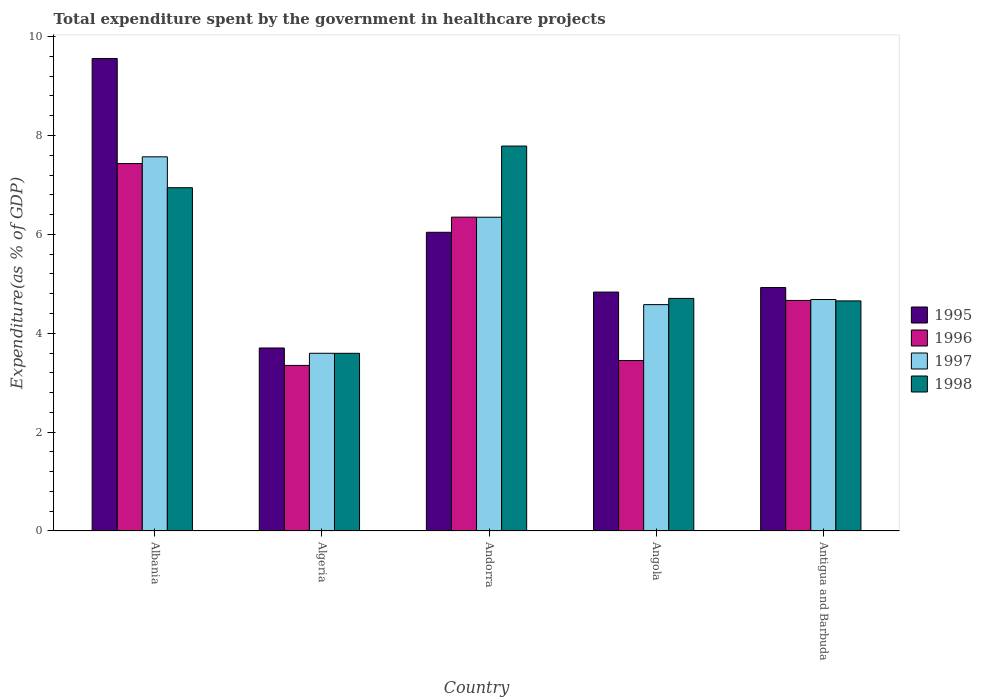How many different coloured bars are there?
Give a very brief answer. 4. How many groups of bars are there?
Keep it short and to the point. 5. Are the number of bars on each tick of the X-axis equal?
Offer a terse response. Yes. How many bars are there on the 3rd tick from the right?
Your answer should be compact. 4. What is the label of the 2nd group of bars from the left?
Provide a short and direct response. Algeria. In how many cases, is the number of bars for a given country not equal to the number of legend labels?
Your answer should be compact. 0. What is the total expenditure spent by the government in healthcare projects in 1998 in Andorra?
Ensure brevity in your answer.  7.79. Across all countries, what is the maximum total expenditure spent by the government in healthcare projects in 1998?
Provide a succinct answer. 7.79. Across all countries, what is the minimum total expenditure spent by the government in healthcare projects in 1995?
Provide a short and direct response. 3.7. In which country was the total expenditure spent by the government in healthcare projects in 1996 maximum?
Make the answer very short. Albania. In which country was the total expenditure spent by the government in healthcare projects in 1997 minimum?
Ensure brevity in your answer.  Algeria. What is the total total expenditure spent by the government in healthcare projects in 1998 in the graph?
Your answer should be very brief. 27.68. What is the difference between the total expenditure spent by the government in healthcare projects in 1998 in Albania and that in Algeria?
Provide a succinct answer. 3.35. What is the difference between the total expenditure spent by the government in healthcare projects in 1995 in Algeria and the total expenditure spent by the government in healthcare projects in 1998 in Albania?
Provide a succinct answer. -3.24. What is the average total expenditure spent by the government in healthcare projects in 1995 per country?
Your response must be concise. 5.81. What is the difference between the total expenditure spent by the government in healthcare projects of/in 1998 and total expenditure spent by the government in healthcare projects of/in 1997 in Algeria?
Give a very brief answer. -0. What is the ratio of the total expenditure spent by the government in healthcare projects in 1998 in Andorra to that in Antigua and Barbuda?
Offer a very short reply. 1.67. Is the total expenditure spent by the government in healthcare projects in 1996 in Albania less than that in Andorra?
Ensure brevity in your answer.  No. What is the difference between the highest and the second highest total expenditure spent by the government in healthcare projects in 1995?
Offer a terse response. 4.63. What is the difference between the highest and the lowest total expenditure spent by the government in healthcare projects in 1997?
Your answer should be very brief. 3.97. In how many countries, is the total expenditure spent by the government in healthcare projects in 1995 greater than the average total expenditure spent by the government in healthcare projects in 1995 taken over all countries?
Your response must be concise. 2. What does the 4th bar from the left in Angola represents?
Ensure brevity in your answer.  1998. Is it the case that in every country, the sum of the total expenditure spent by the government in healthcare projects in 1995 and total expenditure spent by the government in healthcare projects in 1996 is greater than the total expenditure spent by the government in healthcare projects in 1997?
Give a very brief answer. Yes. Are all the bars in the graph horizontal?
Your response must be concise. No. What is the difference between two consecutive major ticks on the Y-axis?
Your response must be concise. 2. Are the values on the major ticks of Y-axis written in scientific E-notation?
Provide a succinct answer. No. Does the graph contain grids?
Provide a short and direct response. No. What is the title of the graph?
Provide a short and direct response. Total expenditure spent by the government in healthcare projects. What is the label or title of the X-axis?
Your response must be concise. Country. What is the label or title of the Y-axis?
Give a very brief answer. Expenditure(as % of GDP). What is the Expenditure(as % of GDP) in 1995 in Albania?
Your answer should be compact. 9.56. What is the Expenditure(as % of GDP) in 1996 in Albania?
Provide a short and direct response. 7.43. What is the Expenditure(as % of GDP) of 1997 in Albania?
Ensure brevity in your answer.  7.57. What is the Expenditure(as % of GDP) in 1998 in Albania?
Your response must be concise. 6.94. What is the Expenditure(as % of GDP) of 1995 in Algeria?
Your response must be concise. 3.7. What is the Expenditure(as % of GDP) in 1996 in Algeria?
Make the answer very short. 3.35. What is the Expenditure(as % of GDP) in 1997 in Algeria?
Your response must be concise. 3.59. What is the Expenditure(as % of GDP) of 1998 in Algeria?
Keep it short and to the point. 3.59. What is the Expenditure(as % of GDP) in 1995 in Andorra?
Your answer should be very brief. 6.04. What is the Expenditure(as % of GDP) of 1996 in Andorra?
Keep it short and to the point. 6.35. What is the Expenditure(as % of GDP) of 1997 in Andorra?
Your answer should be very brief. 6.35. What is the Expenditure(as % of GDP) of 1998 in Andorra?
Offer a very short reply. 7.79. What is the Expenditure(as % of GDP) of 1995 in Angola?
Your answer should be very brief. 4.83. What is the Expenditure(as % of GDP) in 1996 in Angola?
Your answer should be very brief. 3.45. What is the Expenditure(as % of GDP) in 1997 in Angola?
Your response must be concise. 4.58. What is the Expenditure(as % of GDP) of 1998 in Angola?
Ensure brevity in your answer.  4.7. What is the Expenditure(as % of GDP) of 1995 in Antigua and Barbuda?
Your answer should be very brief. 4.92. What is the Expenditure(as % of GDP) of 1996 in Antigua and Barbuda?
Offer a very short reply. 4.66. What is the Expenditure(as % of GDP) in 1997 in Antigua and Barbuda?
Your response must be concise. 4.68. What is the Expenditure(as % of GDP) in 1998 in Antigua and Barbuda?
Offer a very short reply. 4.65. Across all countries, what is the maximum Expenditure(as % of GDP) of 1995?
Your response must be concise. 9.56. Across all countries, what is the maximum Expenditure(as % of GDP) in 1996?
Your answer should be very brief. 7.43. Across all countries, what is the maximum Expenditure(as % of GDP) in 1997?
Provide a short and direct response. 7.57. Across all countries, what is the maximum Expenditure(as % of GDP) of 1998?
Your answer should be very brief. 7.79. Across all countries, what is the minimum Expenditure(as % of GDP) in 1995?
Your answer should be compact. 3.7. Across all countries, what is the minimum Expenditure(as % of GDP) in 1996?
Your response must be concise. 3.35. Across all countries, what is the minimum Expenditure(as % of GDP) in 1997?
Your answer should be compact. 3.59. Across all countries, what is the minimum Expenditure(as % of GDP) in 1998?
Ensure brevity in your answer.  3.59. What is the total Expenditure(as % of GDP) in 1995 in the graph?
Keep it short and to the point. 29.06. What is the total Expenditure(as % of GDP) of 1996 in the graph?
Your answer should be very brief. 25.24. What is the total Expenditure(as % of GDP) in 1997 in the graph?
Ensure brevity in your answer.  26.77. What is the total Expenditure(as % of GDP) in 1998 in the graph?
Provide a short and direct response. 27.68. What is the difference between the Expenditure(as % of GDP) in 1995 in Albania and that in Algeria?
Your response must be concise. 5.86. What is the difference between the Expenditure(as % of GDP) of 1996 in Albania and that in Algeria?
Keep it short and to the point. 4.08. What is the difference between the Expenditure(as % of GDP) in 1997 in Albania and that in Algeria?
Your response must be concise. 3.97. What is the difference between the Expenditure(as % of GDP) in 1998 in Albania and that in Algeria?
Provide a short and direct response. 3.35. What is the difference between the Expenditure(as % of GDP) in 1995 in Albania and that in Andorra?
Provide a short and direct response. 3.52. What is the difference between the Expenditure(as % of GDP) in 1996 in Albania and that in Andorra?
Offer a terse response. 1.08. What is the difference between the Expenditure(as % of GDP) in 1997 in Albania and that in Andorra?
Your answer should be very brief. 1.22. What is the difference between the Expenditure(as % of GDP) in 1998 in Albania and that in Andorra?
Offer a terse response. -0.84. What is the difference between the Expenditure(as % of GDP) of 1995 in Albania and that in Angola?
Offer a very short reply. 4.72. What is the difference between the Expenditure(as % of GDP) in 1996 in Albania and that in Angola?
Make the answer very short. 3.98. What is the difference between the Expenditure(as % of GDP) of 1997 in Albania and that in Angola?
Offer a terse response. 2.99. What is the difference between the Expenditure(as % of GDP) in 1998 in Albania and that in Angola?
Your answer should be compact. 2.24. What is the difference between the Expenditure(as % of GDP) in 1995 in Albania and that in Antigua and Barbuda?
Provide a short and direct response. 4.63. What is the difference between the Expenditure(as % of GDP) in 1996 in Albania and that in Antigua and Barbuda?
Offer a terse response. 2.77. What is the difference between the Expenditure(as % of GDP) of 1997 in Albania and that in Antigua and Barbuda?
Make the answer very short. 2.89. What is the difference between the Expenditure(as % of GDP) of 1998 in Albania and that in Antigua and Barbuda?
Ensure brevity in your answer.  2.29. What is the difference between the Expenditure(as % of GDP) in 1995 in Algeria and that in Andorra?
Keep it short and to the point. -2.34. What is the difference between the Expenditure(as % of GDP) of 1996 in Algeria and that in Andorra?
Your answer should be very brief. -3. What is the difference between the Expenditure(as % of GDP) of 1997 in Algeria and that in Andorra?
Ensure brevity in your answer.  -2.75. What is the difference between the Expenditure(as % of GDP) of 1998 in Algeria and that in Andorra?
Offer a very short reply. -4.19. What is the difference between the Expenditure(as % of GDP) in 1995 in Algeria and that in Angola?
Provide a succinct answer. -1.13. What is the difference between the Expenditure(as % of GDP) of 1996 in Algeria and that in Angola?
Your response must be concise. -0.1. What is the difference between the Expenditure(as % of GDP) in 1997 in Algeria and that in Angola?
Provide a short and direct response. -0.98. What is the difference between the Expenditure(as % of GDP) of 1998 in Algeria and that in Angola?
Provide a short and direct response. -1.11. What is the difference between the Expenditure(as % of GDP) in 1995 in Algeria and that in Antigua and Barbuda?
Offer a terse response. -1.22. What is the difference between the Expenditure(as % of GDP) of 1996 in Algeria and that in Antigua and Barbuda?
Your response must be concise. -1.31. What is the difference between the Expenditure(as % of GDP) of 1997 in Algeria and that in Antigua and Barbuda?
Offer a very short reply. -1.09. What is the difference between the Expenditure(as % of GDP) of 1998 in Algeria and that in Antigua and Barbuda?
Your answer should be compact. -1.06. What is the difference between the Expenditure(as % of GDP) in 1995 in Andorra and that in Angola?
Give a very brief answer. 1.21. What is the difference between the Expenditure(as % of GDP) in 1996 in Andorra and that in Angola?
Offer a very short reply. 2.9. What is the difference between the Expenditure(as % of GDP) of 1997 in Andorra and that in Angola?
Offer a terse response. 1.77. What is the difference between the Expenditure(as % of GDP) of 1998 in Andorra and that in Angola?
Ensure brevity in your answer.  3.08. What is the difference between the Expenditure(as % of GDP) of 1995 in Andorra and that in Antigua and Barbuda?
Offer a terse response. 1.12. What is the difference between the Expenditure(as % of GDP) of 1996 in Andorra and that in Antigua and Barbuda?
Make the answer very short. 1.68. What is the difference between the Expenditure(as % of GDP) in 1997 in Andorra and that in Antigua and Barbuda?
Offer a terse response. 1.66. What is the difference between the Expenditure(as % of GDP) of 1998 in Andorra and that in Antigua and Barbuda?
Keep it short and to the point. 3.13. What is the difference between the Expenditure(as % of GDP) in 1995 in Angola and that in Antigua and Barbuda?
Give a very brief answer. -0.09. What is the difference between the Expenditure(as % of GDP) of 1996 in Angola and that in Antigua and Barbuda?
Your response must be concise. -1.22. What is the difference between the Expenditure(as % of GDP) in 1997 in Angola and that in Antigua and Barbuda?
Provide a short and direct response. -0.1. What is the difference between the Expenditure(as % of GDP) in 1998 in Angola and that in Antigua and Barbuda?
Keep it short and to the point. 0.05. What is the difference between the Expenditure(as % of GDP) of 1995 in Albania and the Expenditure(as % of GDP) of 1996 in Algeria?
Your answer should be very brief. 6.21. What is the difference between the Expenditure(as % of GDP) in 1995 in Albania and the Expenditure(as % of GDP) in 1997 in Algeria?
Your answer should be very brief. 5.96. What is the difference between the Expenditure(as % of GDP) of 1995 in Albania and the Expenditure(as % of GDP) of 1998 in Algeria?
Offer a terse response. 5.96. What is the difference between the Expenditure(as % of GDP) in 1996 in Albania and the Expenditure(as % of GDP) in 1997 in Algeria?
Provide a short and direct response. 3.84. What is the difference between the Expenditure(as % of GDP) of 1996 in Albania and the Expenditure(as % of GDP) of 1998 in Algeria?
Your answer should be compact. 3.84. What is the difference between the Expenditure(as % of GDP) of 1997 in Albania and the Expenditure(as % of GDP) of 1998 in Algeria?
Make the answer very short. 3.97. What is the difference between the Expenditure(as % of GDP) of 1995 in Albania and the Expenditure(as % of GDP) of 1996 in Andorra?
Offer a terse response. 3.21. What is the difference between the Expenditure(as % of GDP) of 1995 in Albania and the Expenditure(as % of GDP) of 1997 in Andorra?
Your answer should be very brief. 3.21. What is the difference between the Expenditure(as % of GDP) of 1995 in Albania and the Expenditure(as % of GDP) of 1998 in Andorra?
Ensure brevity in your answer.  1.77. What is the difference between the Expenditure(as % of GDP) of 1996 in Albania and the Expenditure(as % of GDP) of 1997 in Andorra?
Your answer should be very brief. 1.09. What is the difference between the Expenditure(as % of GDP) of 1996 in Albania and the Expenditure(as % of GDP) of 1998 in Andorra?
Your response must be concise. -0.35. What is the difference between the Expenditure(as % of GDP) in 1997 in Albania and the Expenditure(as % of GDP) in 1998 in Andorra?
Keep it short and to the point. -0.22. What is the difference between the Expenditure(as % of GDP) of 1995 in Albania and the Expenditure(as % of GDP) of 1996 in Angola?
Make the answer very short. 6.11. What is the difference between the Expenditure(as % of GDP) in 1995 in Albania and the Expenditure(as % of GDP) in 1997 in Angola?
Your response must be concise. 4.98. What is the difference between the Expenditure(as % of GDP) of 1995 in Albania and the Expenditure(as % of GDP) of 1998 in Angola?
Offer a terse response. 4.85. What is the difference between the Expenditure(as % of GDP) in 1996 in Albania and the Expenditure(as % of GDP) in 1997 in Angola?
Keep it short and to the point. 2.85. What is the difference between the Expenditure(as % of GDP) of 1996 in Albania and the Expenditure(as % of GDP) of 1998 in Angola?
Make the answer very short. 2.73. What is the difference between the Expenditure(as % of GDP) in 1997 in Albania and the Expenditure(as % of GDP) in 1998 in Angola?
Your answer should be very brief. 2.86. What is the difference between the Expenditure(as % of GDP) in 1995 in Albania and the Expenditure(as % of GDP) in 1996 in Antigua and Barbuda?
Offer a very short reply. 4.89. What is the difference between the Expenditure(as % of GDP) of 1995 in Albania and the Expenditure(as % of GDP) of 1997 in Antigua and Barbuda?
Your answer should be compact. 4.87. What is the difference between the Expenditure(as % of GDP) in 1995 in Albania and the Expenditure(as % of GDP) in 1998 in Antigua and Barbuda?
Make the answer very short. 4.9. What is the difference between the Expenditure(as % of GDP) in 1996 in Albania and the Expenditure(as % of GDP) in 1997 in Antigua and Barbuda?
Give a very brief answer. 2.75. What is the difference between the Expenditure(as % of GDP) of 1996 in Albania and the Expenditure(as % of GDP) of 1998 in Antigua and Barbuda?
Your answer should be very brief. 2.78. What is the difference between the Expenditure(as % of GDP) of 1997 in Albania and the Expenditure(as % of GDP) of 1998 in Antigua and Barbuda?
Make the answer very short. 2.91. What is the difference between the Expenditure(as % of GDP) in 1995 in Algeria and the Expenditure(as % of GDP) in 1996 in Andorra?
Ensure brevity in your answer.  -2.65. What is the difference between the Expenditure(as % of GDP) of 1995 in Algeria and the Expenditure(as % of GDP) of 1997 in Andorra?
Ensure brevity in your answer.  -2.64. What is the difference between the Expenditure(as % of GDP) of 1995 in Algeria and the Expenditure(as % of GDP) of 1998 in Andorra?
Provide a short and direct response. -4.08. What is the difference between the Expenditure(as % of GDP) of 1996 in Algeria and the Expenditure(as % of GDP) of 1997 in Andorra?
Ensure brevity in your answer.  -3. What is the difference between the Expenditure(as % of GDP) of 1996 in Algeria and the Expenditure(as % of GDP) of 1998 in Andorra?
Offer a very short reply. -4.44. What is the difference between the Expenditure(as % of GDP) of 1997 in Algeria and the Expenditure(as % of GDP) of 1998 in Andorra?
Keep it short and to the point. -4.19. What is the difference between the Expenditure(as % of GDP) of 1995 in Algeria and the Expenditure(as % of GDP) of 1996 in Angola?
Make the answer very short. 0.25. What is the difference between the Expenditure(as % of GDP) in 1995 in Algeria and the Expenditure(as % of GDP) in 1997 in Angola?
Provide a short and direct response. -0.88. What is the difference between the Expenditure(as % of GDP) of 1995 in Algeria and the Expenditure(as % of GDP) of 1998 in Angola?
Make the answer very short. -1. What is the difference between the Expenditure(as % of GDP) in 1996 in Algeria and the Expenditure(as % of GDP) in 1997 in Angola?
Give a very brief answer. -1.23. What is the difference between the Expenditure(as % of GDP) in 1996 in Algeria and the Expenditure(as % of GDP) in 1998 in Angola?
Ensure brevity in your answer.  -1.36. What is the difference between the Expenditure(as % of GDP) of 1997 in Algeria and the Expenditure(as % of GDP) of 1998 in Angola?
Keep it short and to the point. -1.11. What is the difference between the Expenditure(as % of GDP) of 1995 in Algeria and the Expenditure(as % of GDP) of 1996 in Antigua and Barbuda?
Make the answer very short. -0.96. What is the difference between the Expenditure(as % of GDP) in 1995 in Algeria and the Expenditure(as % of GDP) in 1997 in Antigua and Barbuda?
Offer a terse response. -0.98. What is the difference between the Expenditure(as % of GDP) in 1995 in Algeria and the Expenditure(as % of GDP) in 1998 in Antigua and Barbuda?
Make the answer very short. -0.95. What is the difference between the Expenditure(as % of GDP) of 1996 in Algeria and the Expenditure(as % of GDP) of 1997 in Antigua and Barbuda?
Offer a very short reply. -1.33. What is the difference between the Expenditure(as % of GDP) of 1996 in Algeria and the Expenditure(as % of GDP) of 1998 in Antigua and Barbuda?
Make the answer very short. -1.3. What is the difference between the Expenditure(as % of GDP) in 1997 in Algeria and the Expenditure(as % of GDP) in 1998 in Antigua and Barbuda?
Your answer should be very brief. -1.06. What is the difference between the Expenditure(as % of GDP) in 1995 in Andorra and the Expenditure(as % of GDP) in 1996 in Angola?
Make the answer very short. 2.59. What is the difference between the Expenditure(as % of GDP) of 1995 in Andorra and the Expenditure(as % of GDP) of 1997 in Angola?
Keep it short and to the point. 1.46. What is the difference between the Expenditure(as % of GDP) in 1995 in Andorra and the Expenditure(as % of GDP) in 1998 in Angola?
Offer a terse response. 1.34. What is the difference between the Expenditure(as % of GDP) in 1996 in Andorra and the Expenditure(as % of GDP) in 1997 in Angola?
Give a very brief answer. 1.77. What is the difference between the Expenditure(as % of GDP) of 1996 in Andorra and the Expenditure(as % of GDP) of 1998 in Angola?
Your answer should be very brief. 1.64. What is the difference between the Expenditure(as % of GDP) of 1997 in Andorra and the Expenditure(as % of GDP) of 1998 in Angola?
Provide a succinct answer. 1.64. What is the difference between the Expenditure(as % of GDP) in 1995 in Andorra and the Expenditure(as % of GDP) in 1996 in Antigua and Barbuda?
Your answer should be very brief. 1.38. What is the difference between the Expenditure(as % of GDP) of 1995 in Andorra and the Expenditure(as % of GDP) of 1997 in Antigua and Barbuda?
Give a very brief answer. 1.36. What is the difference between the Expenditure(as % of GDP) of 1995 in Andorra and the Expenditure(as % of GDP) of 1998 in Antigua and Barbuda?
Your answer should be compact. 1.39. What is the difference between the Expenditure(as % of GDP) of 1996 in Andorra and the Expenditure(as % of GDP) of 1997 in Antigua and Barbuda?
Offer a terse response. 1.67. What is the difference between the Expenditure(as % of GDP) of 1996 in Andorra and the Expenditure(as % of GDP) of 1998 in Antigua and Barbuda?
Your response must be concise. 1.69. What is the difference between the Expenditure(as % of GDP) of 1997 in Andorra and the Expenditure(as % of GDP) of 1998 in Antigua and Barbuda?
Your answer should be compact. 1.69. What is the difference between the Expenditure(as % of GDP) in 1995 in Angola and the Expenditure(as % of GDP) in 1996 in Antigua and Barbuda?
Provide a succinct answer. 0.17. What is the difference between the Expenditure(as % of GDP) in 1995 in Angola and the Expenditure(as % of GDP) in 1997 in Antigua and Barbuda?
Provide a succinct answer. 0.15. What is the difference between the Expenditure(as % of GDP) in 1995 in Angola and the Expenditure(as % of GDP) in 1998 in Antigua and Barbuda?
Ensure brevity in your answer.  0.18. What is the difference between the Expenditure(as % of GDP) of 1996 in Angola and the Expenditure(as % of GDP) of 1997 in Antigua and Barbuda?
Ensure brevity in your answer.  -1.23. What is the difference between the Expenditure(as % of GDP) of 1996 in Angola and the Expenditure(as % of GDP) of 1998 in Antigua and Barbuda?
Ensure brevity in your answer.  -1.21. What is the difference between the Expenditure(as % of GDP) in 1997 in Angola and the Expenditure(as % of GDP) in 1998 in Antigua and Barbuda?
Your answer should be compact. -0.08. What is the average Expenditure(as % of GDP) of 1995 per country?
Your answer should be very brief. 5.81. What is the average Expenditure(as % of GDP) in 1996 per country?
Offer a very short reply. 5.05. What is the average Expenditure(as % of GDP) in 1997 per country?
Keep it short and to the point. 5.35. What is the average Expenditure(as % of GDP) of 1998 per country?
Provide a succinct answer. 5.54. What is the difference between the Expenditure(as % of GDP) of 1995 and Expenditure(as % of GDP) of 1996 in Albania?
Your response must be concise. 2.12. What is the difference between the Expenditure(as % of GDP) in 1995 and Expenditure(as % of GDP) in 1997 in Albania?
Your response must be concise. 1.99. What is the difference between the Expenditure(as % of GDP) of 1995 and Expenditure(as % of GDP) of 1998 in Albania?
Your answer should be compact. 2.61. What is the difference between the Expenditure(as % of GDP) in 1996 and Expenditure(as % of GDP) in 1997 in Albania?
Offer a terse response. -0.14. What is the difference between the Expenditure(as % of GDP) in 1996 and Expenditure(as % of GDP) in 1998 in Albania?
Offer a terse response. 0.49. What is the difference between the Expenditure(as % of GDP) of 1997 and Expenditure(as % of GDP) of 1998 in Albania?
Give a very brief answer. 0.62. What is the difference between the Expenditure(as % of GDP) in 1995 and Expenditure(as % of GDP) in 1996 in Algeria?
Provide a short and direct response. 0.35. What is the difference between the Expenditure(as % of GDP) in 1995 and Expenditure(as % of GDP) in 1997 in Algeria?
Keep it short and to the point. 0.11. What is the difference between the Expenditure(as % of GDP) of 1995 and Expenditure(as % of GDP) of 1998 in Algeria?
Provide a succinct answer. 0.11. What is the difference between the Expenditure(as % of GDP) of 1996 and Expenditure(as % of GDP) of 1997 in Algeria?
Keep it short and to the point. -0.25. What is the difference between the Expenditure(as % of GDP) in 1996 and Expenditure(as % of GDP) in 1998 in Algeria?
Give a very brief answer. -0.24. What is the difference between the Expenditure(as % of GDP) in 1997 and Expenditure(as % of GDP) in 1998 in Algeria?
Offer a terse response. 0. What is the difference between the Expenditure(as % of GDP) in 1995 and Expenditure(as % of GDP) in 1996 in Andorra?
Ensure brevity in your answer.  -0.31. What is the difference between the Expenditure(as % of GDP) in 1995 and Expenditure(as % of GDP) in 1997 in Andorra?
Provide a short and direct response. -0.3. What is the difference between the Expenditure(as % of GDP) in 1995 and Expenditure(as % of GDP) in 1998 in Andorra?
Provide a succinct answer. -1.74. What is the difference between the Expenditure(as % of GDP) of 1996 and Expenditure(as % of GDP) of 1997 in Andorra?
Your answer should be very brief. 0. What is the difference between the Expenditure(as % of GDP) in 1996 and Expenditure(as % of GDP) in 1998 in Andorra?
Make the answer very short. -1.44. What is the difference between the Expenditure(as % of GDP) of 1997 and Expenditure(as % of GDP) of 1998 in Andorra?
Provide a succinct answer. -1.44. What is the difference between the Expenditure(as % of GDP) in 1995 and Expenditure(as % of GDP) in 1996 in Angola?
Your answer should be compact. 1.38. What is the difference between the Expenditure(as % of GDP) in 1995 and Expenditure(as % of GDP) in 1997 in Angola?
Provide a short and direct response. 0.25. What is the difference between the Expenditure(as % of GDP) of 1995 and Expenditure(as % of GDP) of 1998 in Angola?
Provide a short and direct response. 0.13. What is the difference between the Expenditure(as % of GDP) in 1996 and Expenditure(as % of GDP) in 1997 in Angola?
Your answer should be compact. -1.13. What is the difference between the Expenditure(as % of GDP) in 1996 and Expenditure(as % of GDP) in 1998 in Angola?
Provide a short and direct response. -1.26. What is the difference between the Expenditure(as % of GDP) in 1997 and Expenditure(as % of GDP) in 1998 in Angola?
Your answer should be compact. -0.13. What is the difference between the Expenditure(as % of GDP) of 1995 and Expenditure(as % of GDP) of 1996 in Antigua and Barbuda?
Your response must be concise. 0.26. What is the difference between the Expenditure(as % of GDP) of 1995 and Expenditure(as % of GDP) of 1997 in Antigua and Barbuda?
Your response must be concise. 0.24. What is the difference between the Expenditure(as % of GDP) in 1995 and Expenditure(as % of GDP) in 1998 in Antigua and Barbuda?
Your answer should be compact. 0.27. What is the difference between the Expenditure(as % of GDP) of 1996 and Expenditure(as % of GDP) of 1997 in Antigua and Barbuda?
Offer a very short reply. -0.02. What is the difference between the Expenditure(as % of GDP) in 1996 and Expenditure(as % of GDP) in 1998 in Antigua and Barbuda?
Offer a terse response. 0.01. What is the difference between the Expenditure(as % of GDP) of 1997 and Expenditure(as % of GDP) of 1998 in Antigua and Barbuda?
Give a very brief answer. 0.03. What is the ratio of the Expenditure(as % of GDP) in 1995 in Albania to that in Algeria?
Ensure brevity in your answer.  2.58. What is the ratio of the Expenditure(as % of GDP) of 1996 in Albania to that in Algeria?
Offer a very short reply. 2.22. What is the ratio of the Expenditure(as % of GDP) of 1997 in Albania to that in Algeria?
Ensure brevity in your answer.  2.11. What is the ratio of the Expenditure(as % of GDP) in 1998 in Albania to that in Algeria?
Offer a very short reply. 1.93. What is the ratio of the Expenditure(as % of GDP) in 1995 in Albania to that in Andorra?
Ensure brevity in your answer.  1.58. What is the ratio of the Expenditure(as % of GDP) of 1996 in Albania to that in Andorra?
Offer a terse response. 1.17. What is the ratio of the Expenditure(as % of GDP) of 1997 in Albania to that in Andorra?
Your answer should be very brief. 1.19. What is the ratio of the Expenditure(as % of GDP) of 1998 in Albania to that in Andorra?
Offer a very short reply. 0.89. What is the ratio of the Expenditure(as % of GDP) in 1995 in Albania to that in Angola?
Offer a very short reply. 1.98. What is the ratio of the Expenditure(as % of GDP) in 1996 in Albania to that in Angola?
Offer a terse response. 2.16. What is the ratio of the Expenditure(as % of GDP) in 1997 in Albania to that in Angola?
Provide a short and direct response. 1.65. What is the ratio of the Expenditure(as % of GDP) of 1998 in Albania to that in Angola?
Your answer should be very brief. 1.48. What is the ratio of the Expenditure(as % of GDP) in 1995 in Albania to that in Antigua and Barbuda?
Provide a succinct answer. 1.94. What is the ratio of the Expenditure(as % of GDP) in 1996 in Albania to that in Antigua and Barbuda?
Offer a terse response. 1.59. What is the ratio of the Expenditure(as % of GDP) of 1997 in Albania to that in Antigua and Barbuda?
Ensure brevity in your answer.  1.62. What is the ratio of the Expenditure(as % of GDP) of 1998 in Albania to that in Antigua and Barbuda?
Offer a terse response. 1.49. What is the ratio of the Expenditure(as % of GDP) in 1995 in Algeria to that in Andorra?
Offer a very short reply. 0.61. What is the ratio of the Expenditure(as % of GDP) of 1996 in Algeria to that in Andorra?
Give a very brief answer. 0.53. What is the ratio of the Expenditure(as % of GDP) of 1997 in Algeria to that in Andorra?
Your answer should be very brief. 0.57. What is the ratio of the Expenditure(as % of GDP) in 1998 in Algeria to that in Andorra?
Provide a short and direct response. 0.46. What is the ratio of the Expenditure(as % of GDP) of 1995 in Algeria to that in Angola?
Provide a short and direct response. 0.77. What is the ratio of the Expenditure(as % of GDP) of 1996 in Algeria to that in Angola?
Keep it short and to the point. 0.97. What is the ratio of the Expenditure(as % of GDP) of 1997 in Algeria to that in Angola?
Provide a short and direct response. 0.79. What is the ratio of the Expenditure(as % of GDP) of 1998 in Algeria to that in Angola?
Provide a succinct answer. 0.76. What is the ratio of the Expenditure(as % of GDP) of 1995 in Algeria to that in Antigua and Barbuda?
Your answer should be compact. 0.75. What is the ratio of the Expenditure(as % of GDP) of 1996 in Algeria to that in Antigua and Barbuda?
Give a very brief answer. 0.72. What is the ratio of the Expenditure(as % of GDP) of 1997 in Algeria to that in Antigua and Barbuda?
Provide a short and direct response. 0.77. What is the ratio of the Expenditure(as % of GDP) of 1998 in Algeria to that in Antigua and Barbuda?
Offer a terse response. 0.77. What is the ratio of the Expenditure(as % of GDP) of 1995 in Andorra to that in Angola?
Offer a very short reply. 1.25. What is the ratio of the Expenditure(as % of GDP) in 1996 in Andorra to that in Angola?
Offer a very short reply. 1.84. What is the ratio of the Expenditure(as % of GDP) in 1997 in Andorra to that in Angola?
Make the answer very short. 1.39. What is the ratio of the Expenditure(as % of GDP) in 1998 in Andorra to that in Angola?
Give a very brief answer. 1.65. What is the ratio of the Expenditure(as % of GDP) of 1995 in Andorra to that in Antigua and Barbuda?
Provide a short and direct response. 1.23. What is the ratio of the Expenditure(as % of GDP) in 1996 in Andorra to that in Antigua and Barbuda?
Your answer should be very brief. 1.36. What is the ratio of the Expenditure(as % of GDP) in 1997 in Andorra to that in Antigua and Barbuda?
Ensure brevity in your answer.  1.36. What is the ratio of the Expenditure(as % of GDP) in 1998 in Andorra to that in Antigua and Barbuda?
Provide a short and direct response. 1.67. What is the ratio of the Expenditure(as % of GDP) in 1995 in Angola to that in Antigua and Barbuda?
Make the answer very short. 0.98. What is the ratio of the Expenditure(as % of GDP) of 1996 in Angola to that in Antigua and Barbuda?
Your response must be concise. 0.74. What is the ratio of the Expenditure(as % of GDP) of 1997 in Angola to that in Antigua and Barbuda?
Make the answer very short. 0.98. What is the ratio of the Expenditure(as % of GDP) of 1998 in Angola to that in Antigua and Barbuda?
Make the answer very short. 1.01. What is the difference between the highest and the second highest Expenditure(as % of GDP) of 1995?
Your answer should be very brief. 3.52. What is the difference between the highest and the second highest Expenditure(as % of GDP) of 1996?
Offer a terse response. 1.08. What is the difference between the highest and the second highest Expenditure(as % of GDP) in 1997?
Offer a very short reply. 1.22. What is the difference between the highest and the second highest Expenditure(as % of GDP) in 1998?
Keep it short and to the point. 0.84. What is the difference between the highest and the lowest Expenditure(as % of GDP) in 1995?
Give a very brief answer. 5.86. What is the difference between the highest and the lowest Expenditure(as % of GDP) of 1996?
Your response must be concise. 4.08. What is the difference between the highest and the lowest Expenditure(as % of GDP) of 1997?
Provide a succinct answer. 3.97. What is the difference between the highest and the lowest Expenditure(as % of GDP) of 1998?
Your answer should be very brief. 4.19. 